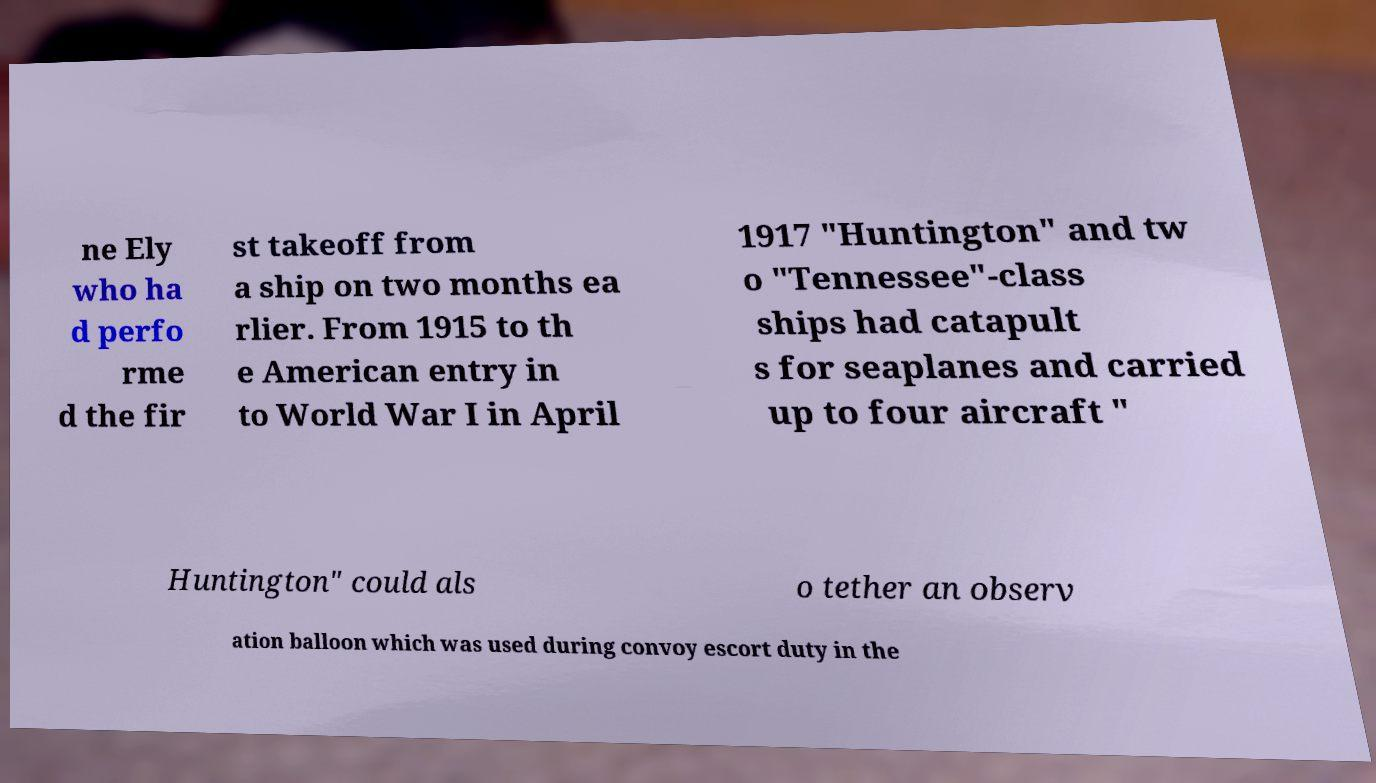For documentation purposes, I need the text within this image transcribed. Could you provide that? ne Ely who ha d perfo rme d the fir st takeoff from a ship on two months ea rlier. From 1915 to th e American entry in to World War I in April 1917 "Huntington" and tw o "Tennessee"-class ships had catapult s for seaplanes and carried up to four aircraft " Huntington" could als o tether an observ ation balloon which was used during convoy escort duty in the 